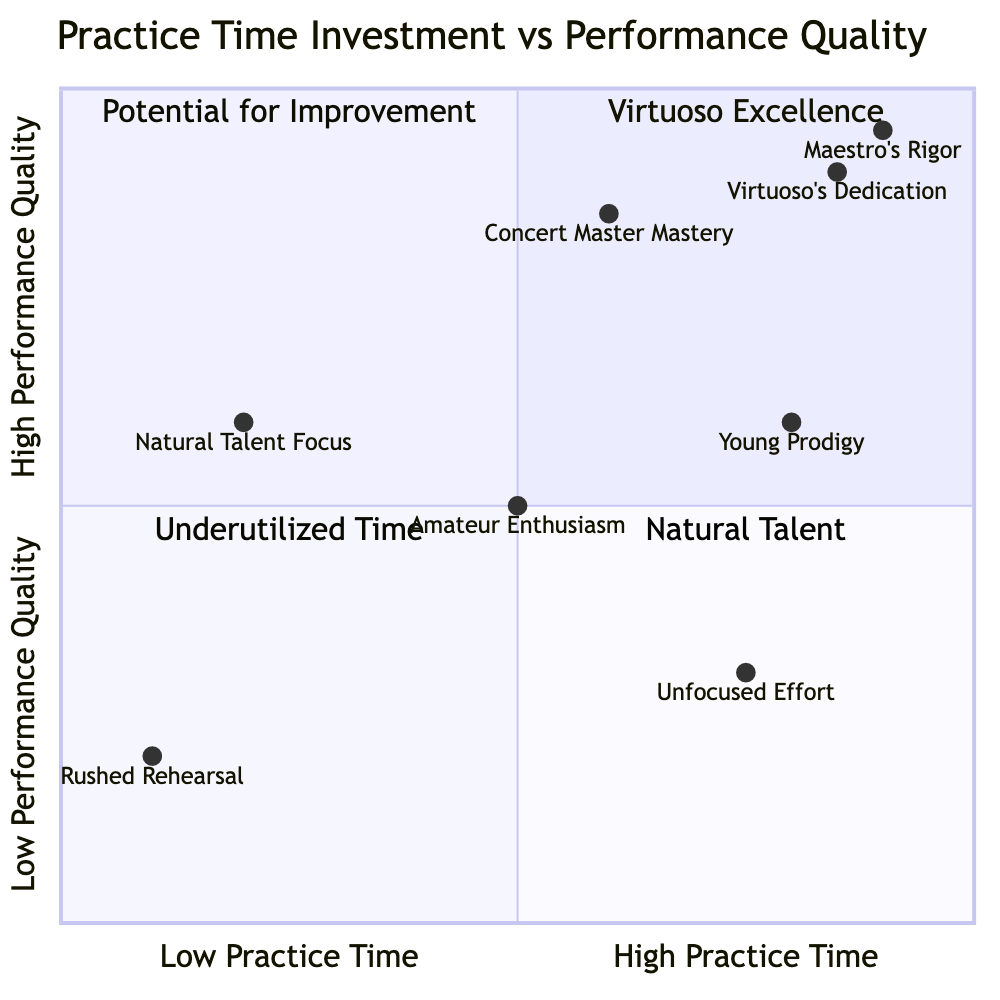What's the performance quality of "Maestro's Rigor"? The diagram shows that "Maestro's Rigor" is positioned at a high performance quality value of 0.95.
Answer: High How many elements are in the "Virtuoso Excellence" quadrant? In the "Virtuoso Excellence" quadrant, two elements are located: "Maestro's Rigor" and "Virtuoso's Dedication."
Answer: 2 Which element has low practice time and high performance quality? The diagram indicates that "Natural Talent Focus" has low practice time (0.2) and medium performance quality (0.6), but no element falls into the criteria of low practice and high performance quality.
Answer: None What is the highest practice time of all the elements shown? Upon examining the diagram, "Maestro's Rigor," "Virtuoso's Dedication," and "Young Prodigy" all exhibit high practice time, which is the highest category represented in the chart.
Answer: High Which element is closest to the "Underutilized Time" quadrant? The "Natural Talent Focus" is closest to the "Underutilized Time" quadrant, as it occupies the coordinate closest to the left side (low practice time) while still maintaining decent performance quality.
Answer: Natural Talent Focus What does the "Concert Master Mastery" represent in terms of practice time and performance quality? "Concert Master Mastery" is categorized under medium practice time (0.6) and high performance quality (0.85), indicating a balanced approach to practice and skill enhancement.
Answer: Medium practice time, high performance quality Which quadrant contains the "Rushed Rehearsal"? "Rushed Rehearsal," based on its low practice time and low performance quality, is clearly located in the "Natural Talent" quadrant.
Answer: Natural Talent What performance quality does the "Unfocused Effort" element have? The "Unfocused Effort" element is shown to have a performance quality value of 0.3, indicating low performance quality despite high practice time.
Answer: Low 